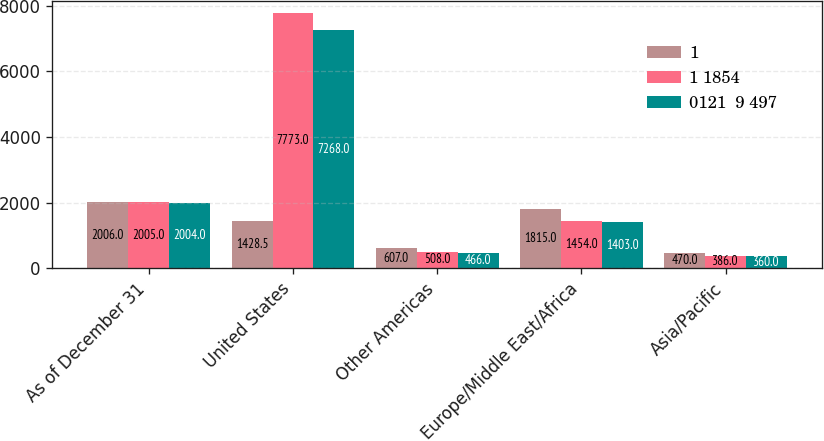Convert chart to OTSL. <chart><loc_0><loc_0><loc_500><loc_500><stacked_bar_chart><ecel><fcel>As of December 31<fcel>United States<fcel>Other Americas<fcel>Europe/Middle East/Africa<fcel>Asia/Pacific<nl><fcel>1<fcel>2006<fcel>1428.5<fcel>607<fcel>1815<fcel>470<nl><fcel>1 1854<fcel>2005<fcel>7773<fcel>508<fcel>1454<fcel>386<nl><fcel>0121  9 497<fcel>2004<fcel>7268<fcel>466<fcel>1403<fcel>360<nl></chart> 